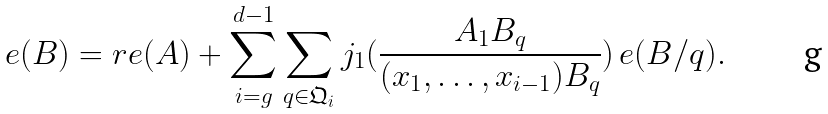<formula> <loc_0><loc_0><loc_500><loc_500>e ( B ) = r e ( A ) + \sum _ { i = g } ^ { d - 1 } \sum _ { q \in \mathfrak { Q } _ { i } } j _ { 1 } ( \frac { A _ { 1 } B _ { q } } { ( x _ { 1 } , \dots , x _ { i - 1 } ) B _ { q } } ) \, e ( B / q ) .</formula> 